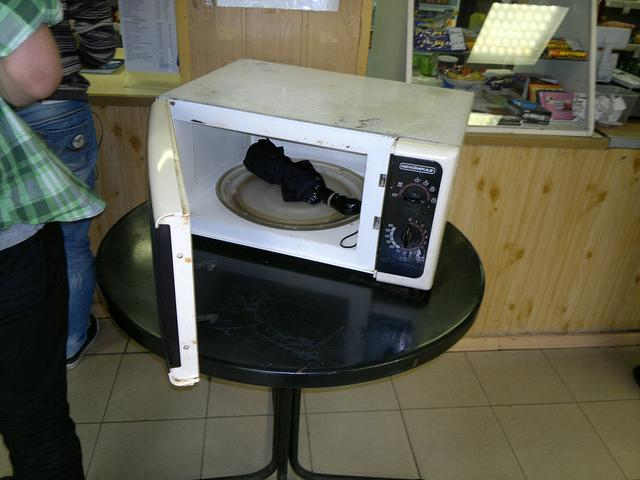Inside what is the umbrella? microwave 